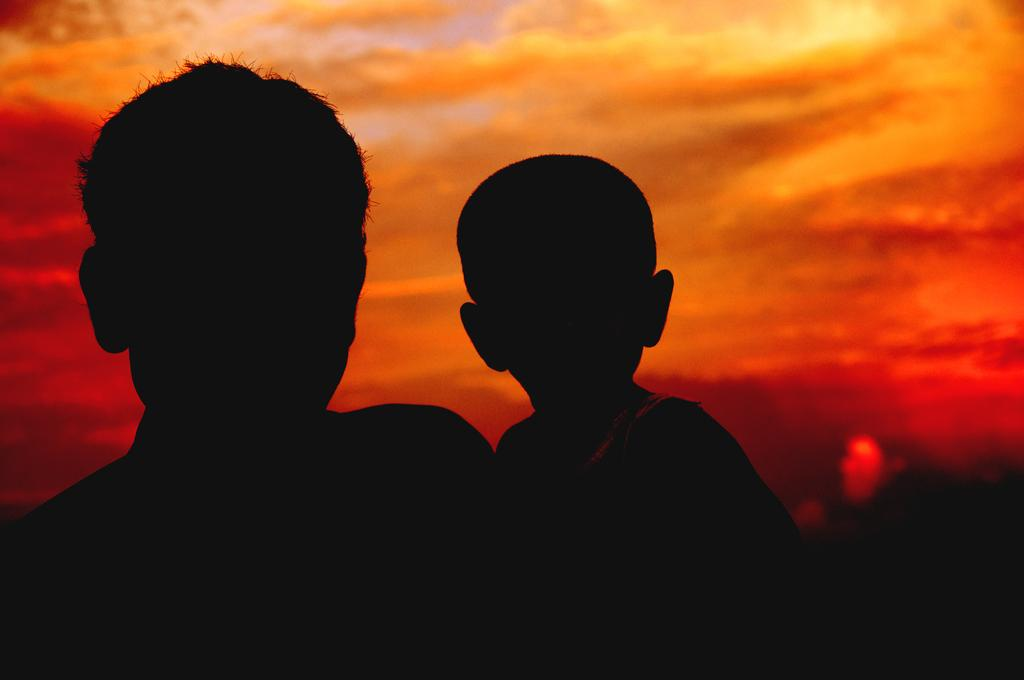What is the person in the image holding? The person in the image is holding a baby. What can be seen in the background of the image? The sky is red in color in the background of the image. What type of volleyball is being played in the image? There is no volleyball present in the image. What kind of rose is being held by the person in the image? There is no rose present in the image; the person is holding a baby. 